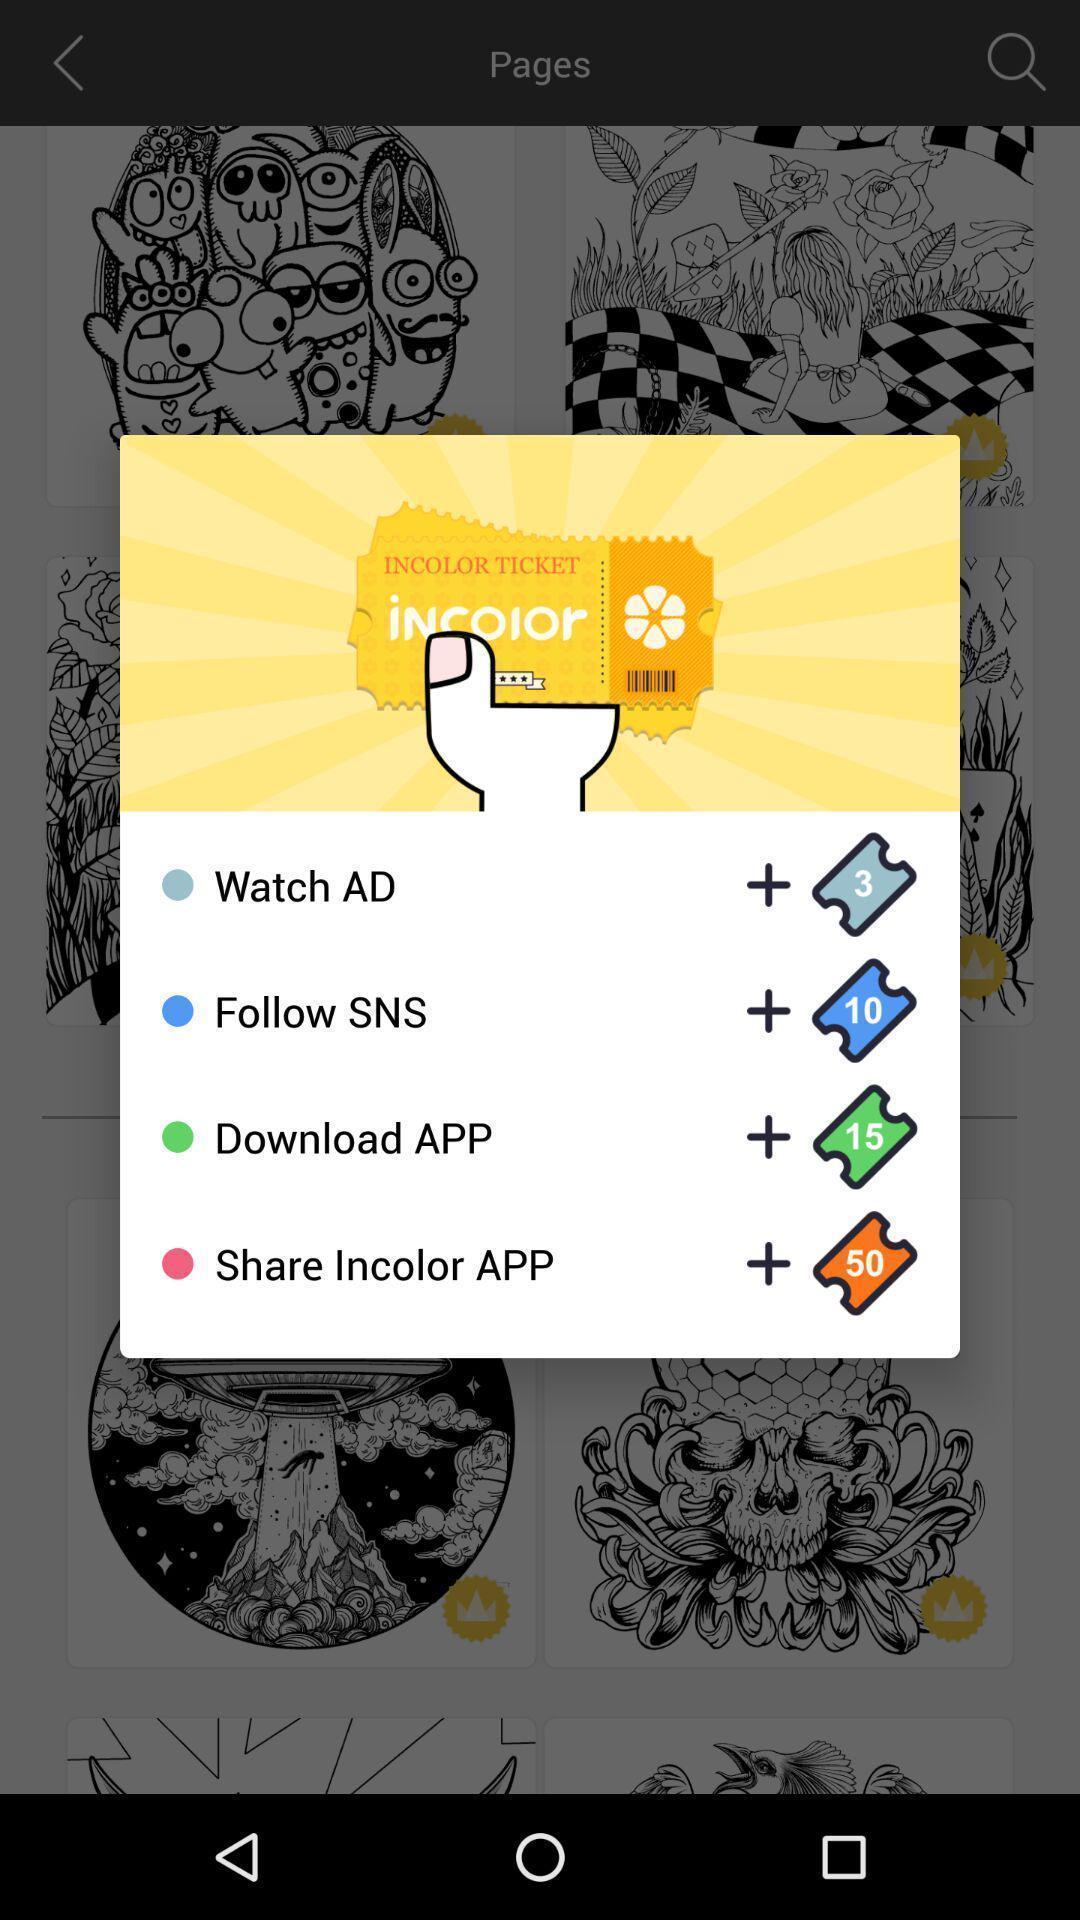Provide a description of this screenshot. Pop up showing various options in art application. 